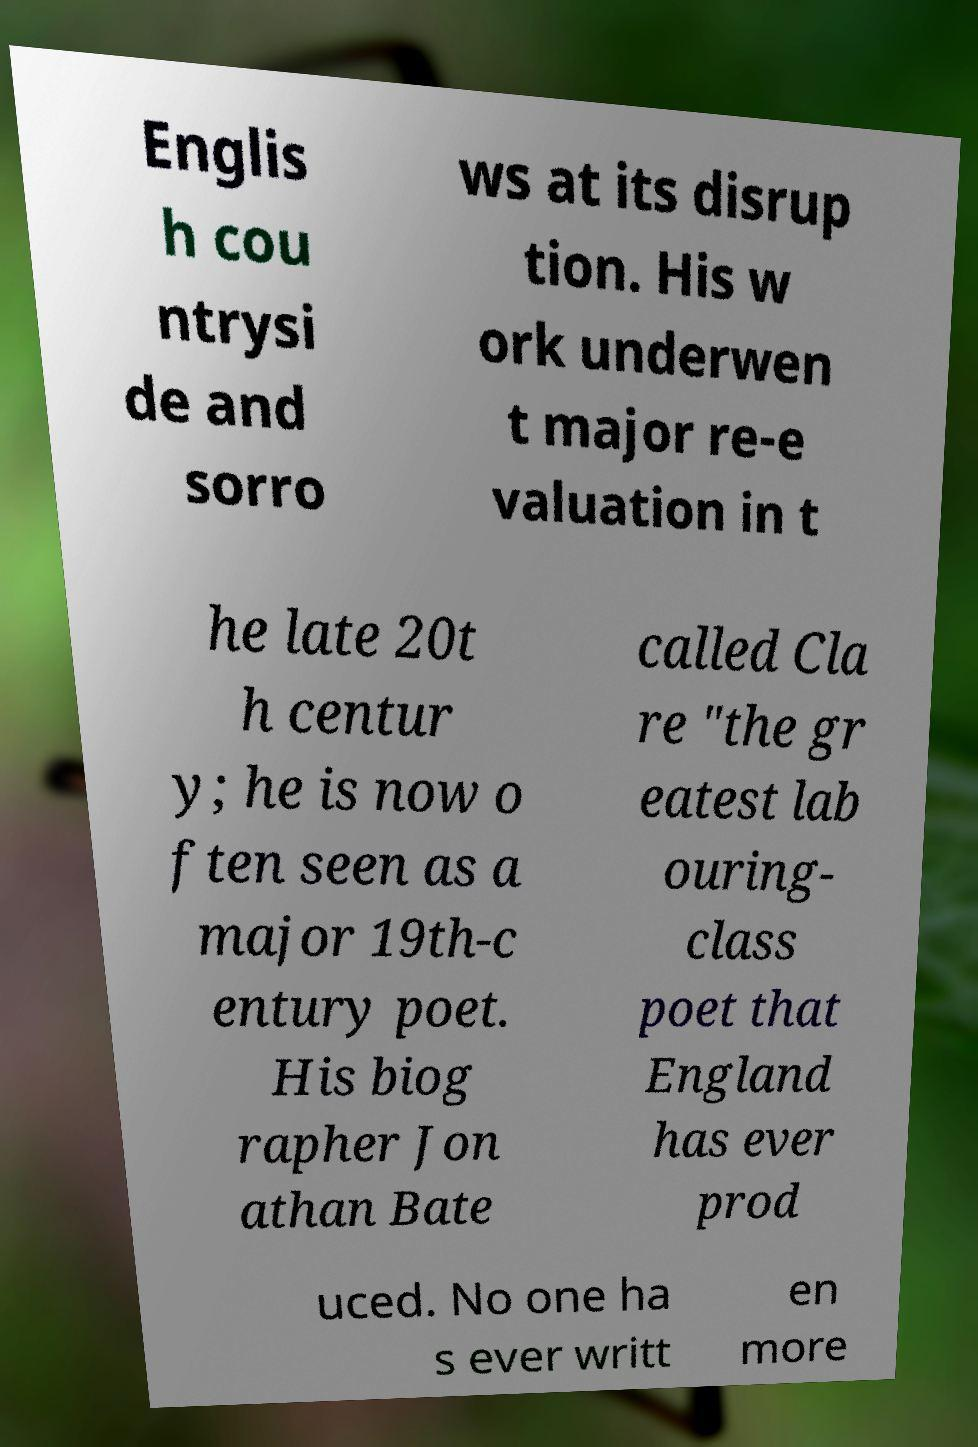Could you extract and type out the text from this image? Englis h cou ntrysi de and sorro ws at its disrup tion. His w ork underwen t major re-e valuation in t he late 20t h centur y; he is now o ften seen as a major 19th-c entury poet. His biog rapher Jon athan Bate called Cla re "the gr eatest lab ouring- class poet that England has ever prod uced. No one ha s ever writt en more 